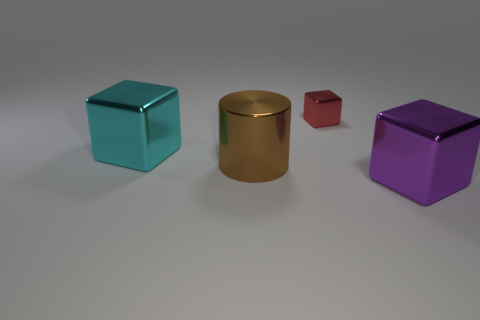Subtract all green cubes. Subtract all purple balls. How many cubes are left? 3 Add 4 blocks. How many objects exist? 8 Subtract all cylinders. How many objects are left? 3 Subtract all big cylinders. Subtract all big purple metallic cubes. How many objects are left? 2 Add 1 big brown metallic cylinders. How many big brown metallic cylinders are left? 2 Add 1 metal cylinders. How many metal cylinders exist? 2 Subtract 0 brown balls. How many objects are left? 4 